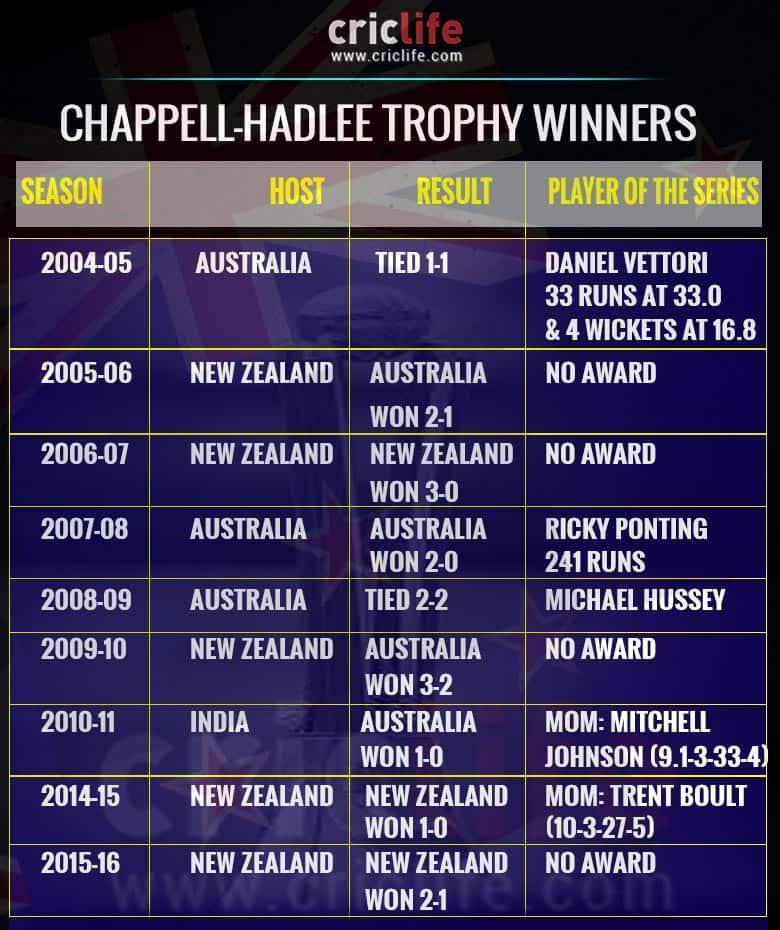How many times does Australia become a host?
Answer the question with a short phrase. 3 How many times does New Zealand become a host? 5 For how many years no awards for the title player of the series? 4 